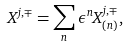Convert formula to latex. <formula><loc_0><loc_0><loc_500><loc_500>X ^ { j , \mp } = \sum _ { n } \epsilon ^ { n } X _ { \left ( n \right ) } ^ { j , \mp } ,</formula> 